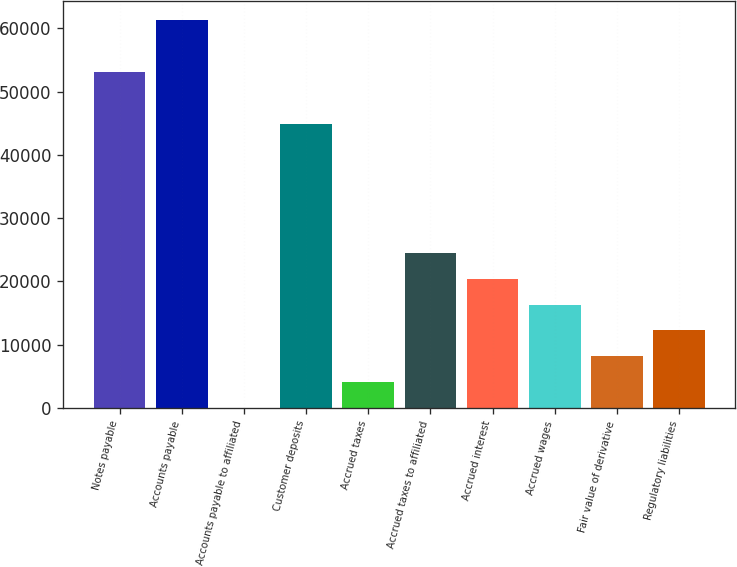Convert chart. <chart><loc_0><loc_0><loc_500><loc_500><bar_chart><fcel>Notes payable<fcel>Accounts payable<fcel>Accounts payable to affiliated<fcel>Customer deposits<fcel>Accrued taxes<fcel>Accrued taxes to affiliated<fcel>Accrued interest<fcel>Accrued wages<fcel>Fair value of derivative<fcel>Regulatory liabilities<nl><fcel>53109.8<fcel>61279<fcel>10<fcel>44940.6<fcel>4094.6<fcel>24517.6<fcel>20433<fcel>16348.4<fcel>8179.2<fcel>12263.8<nl></chart> 